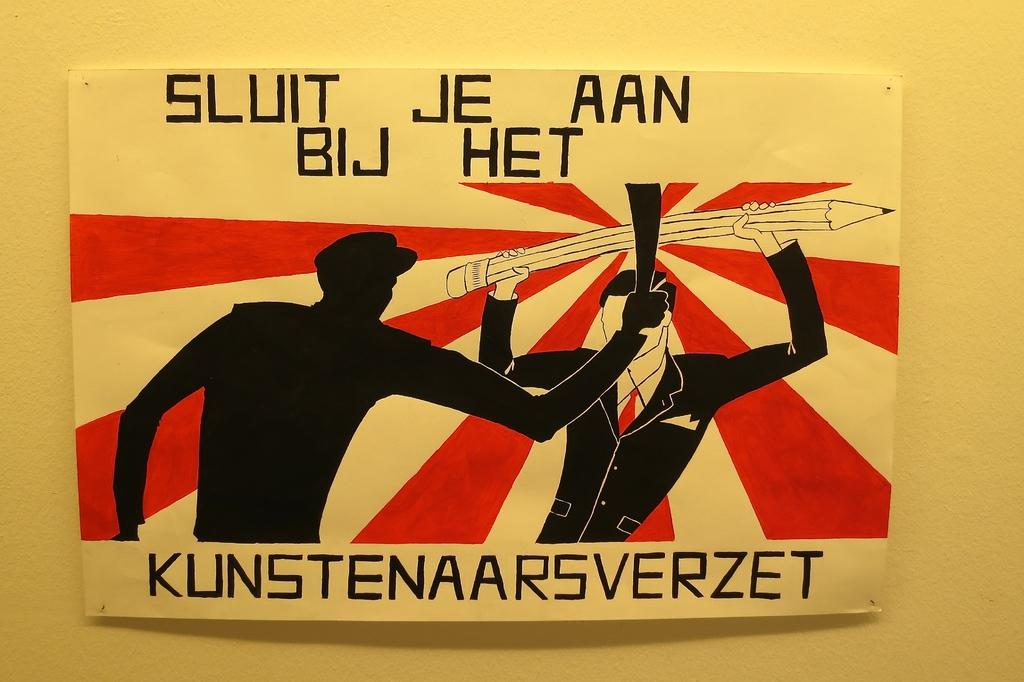<image>
Offer a succinct explanation of the picture presented. Two men are fighting, one with a large sword and the other with a large pencil on an antique poster from (Kunstenaarsverzet) Amsterdam. 